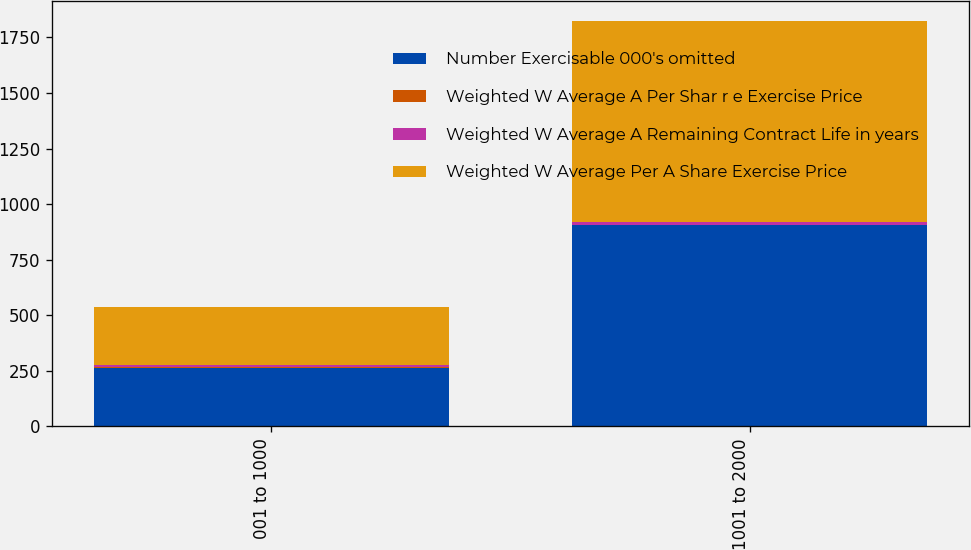<chart> <loc_0><loc_0><loc_500><loc_500><stacked_bar_chart><ecel><fcel>001 to 1000<fcel>1001 to 2000<nl><fcel>Number Exercisable 000's omitted<fcel>264<fcel>904<nl><fcel>Weighted W Average A Per Shar r e Exercise Price<fcel>2.9<fcel>1.6<nl><fcel>Weighted W Average A Remaining Contract Life in years<fcel>8<fcel>12<nl><fcel>Weighted W Average Per A Share Exercise Price<fcel>264<fcel>904<nl></chart> 